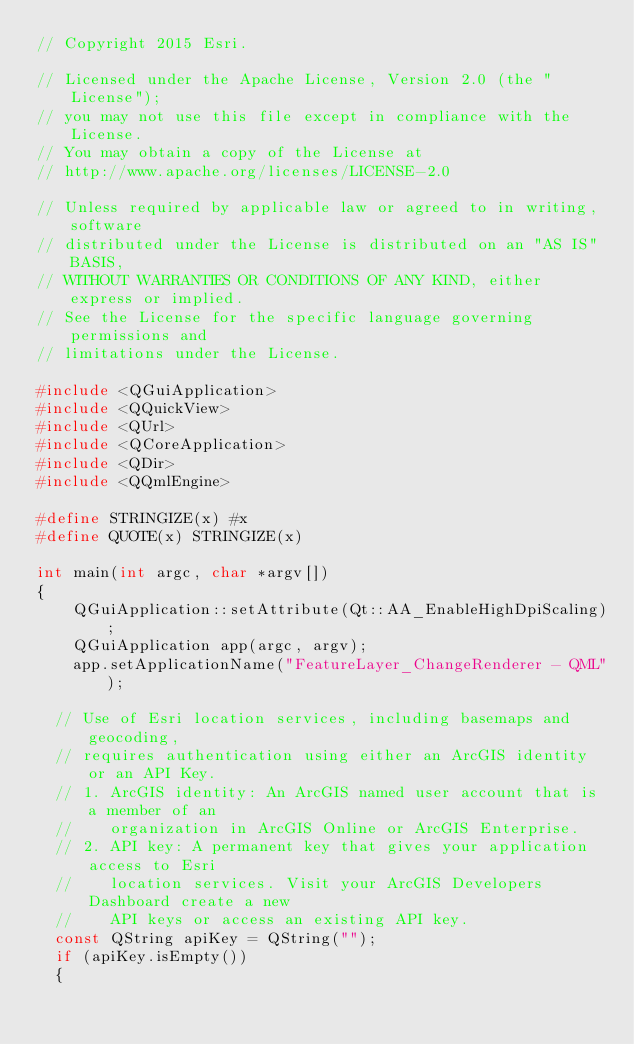Convert code to text. <code><loc_0><loc_0><loc_500><loc_500><_C++_>// Copyright 2015 Esri.

// Licensed under the Apache License, Version 2.0 (the "License");
// you may not use this file except in compliance with the License.
// You may obtain a copy of the License at
// http://www.apache.org/licenses/LICENSE-2.0

// Unless required by applicable law or agreed to in writing, software
// distributed under the License is distributed on an "AS IS" BASIS,
// WITHOUT WARRANTIES OR CONDITIONS OF ANY KIND, either express or implied.
// See the License for the specific language governing permissions and
// limitations under the License.

#include <QGuiApplication>
#include <QQuickView>
#include <QUrl>
#include <QCoreApplication>
#include <QDir>
#include <QQmlEngine>

#define STRINGIZE(x) #x
#define QUOTE(x) STRINGIZE(x)

int main(int argc, char *argv[])
{
    QGuiApplication::setAttribute(Qt::AA_EnableHighDpiScaling);
    QGuiApplication app(argc, argv);
    app.setApplicationName("FeatureLayer_ChangeRenderer - QML");

  // Use of Esri location services, including basemaps and geocoding,
  // requires authentication using either an ArcGIS identity or an API Key.
  // 1. ArcGIS identity: An ArcGIS named user account that is a member of an
  //    organization in ArcGIS Online or ArcGIS Enterprise.
  // 2. API key: A permanent key that gives your application access to Esri
  //    location services. Visit your ArcGIS Developers Dashboard create a new
  //    API keys or access an existing API key.
  const QString apiKey = QString("");
  if (apiKey.isEmpty())
  {</code> 